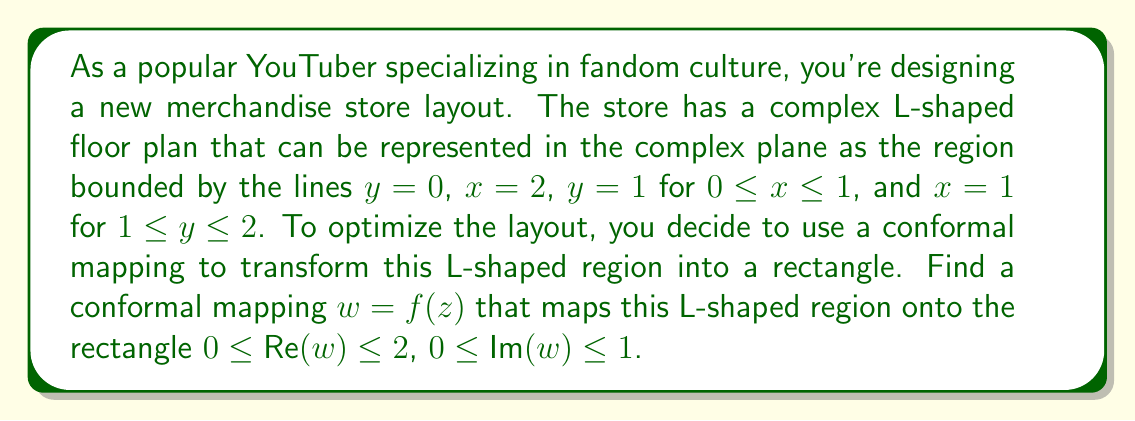Show me your answer to this math problem. To solve this problem, we'll use the Schwarz-Christoffel transformation, which is a powerful tool for conformally mapping polygonal regions to simpler shapes. Here's the step-by-step process:

1) First, we need to identify the vertices of our L-shaped region in the complex plane:
   $z_1 = 0$, $z_2 = 1$, $z_3 = 1+i$, $z_4 = 2+i$, $z_5 = 2$

2) We want to map these points to the corners of a rectangle. Let's choose:
   $w_1 = 0$, $w_2 = 1$, $w_3 = 1+i$, $w_4 = 2+i$, $w_5 = 2$

3) The general form of the Schwarz-Christoffel transformation for this case is:

   $$f(z) = A \int_0^z \frac{d\zeta}{(\zeta-1)^{1/2}(\zeta-2)^{1/2}} + B$$

   where $A$ and $B$ are complex constants to be determined.

4) This integral can be evaluated in terms of elliptic integrals. However, for our purposes, we can express it as:

   $$f(z) = A \cdot F(z) + B$$

   where $F(z)$ is the antiderivative of $\frac{1}{(\zeta-1)^{1/2}(\zeta-2)^{1/2}}$.

5) To determine $A$ and $B$, we can use the fact that $f(0) = 0$ and $f(2) = 2$:

   $0 = A \cdot F(0) + B$
   $2 = A \cdot F(2) + B$

6) Solving these equations:

   $B = -A \cdot F(0)$
   $A = \frac{2}{F(2) - F(0)}$

7) Therefore, our conformal mapping is:

   $$f(z) = \frac{2}{F(2) - F(0)} \cdot (F(z) - F(0))$$

This function $f(z)$ conformally maps the L-shaped region onto the desired rectangle.
Answer: The conformal mapping from the L-shaped region to the rectangle is:

$$f(z) = \frac{2}{F(2) - F(0)} \cdot (F(z) - F(0))$$

where $F(z)$ is the antiderivative of $\frac{1}{(\zeta-1)^{1/2}(\zeta-2)^{1/2}}$. 